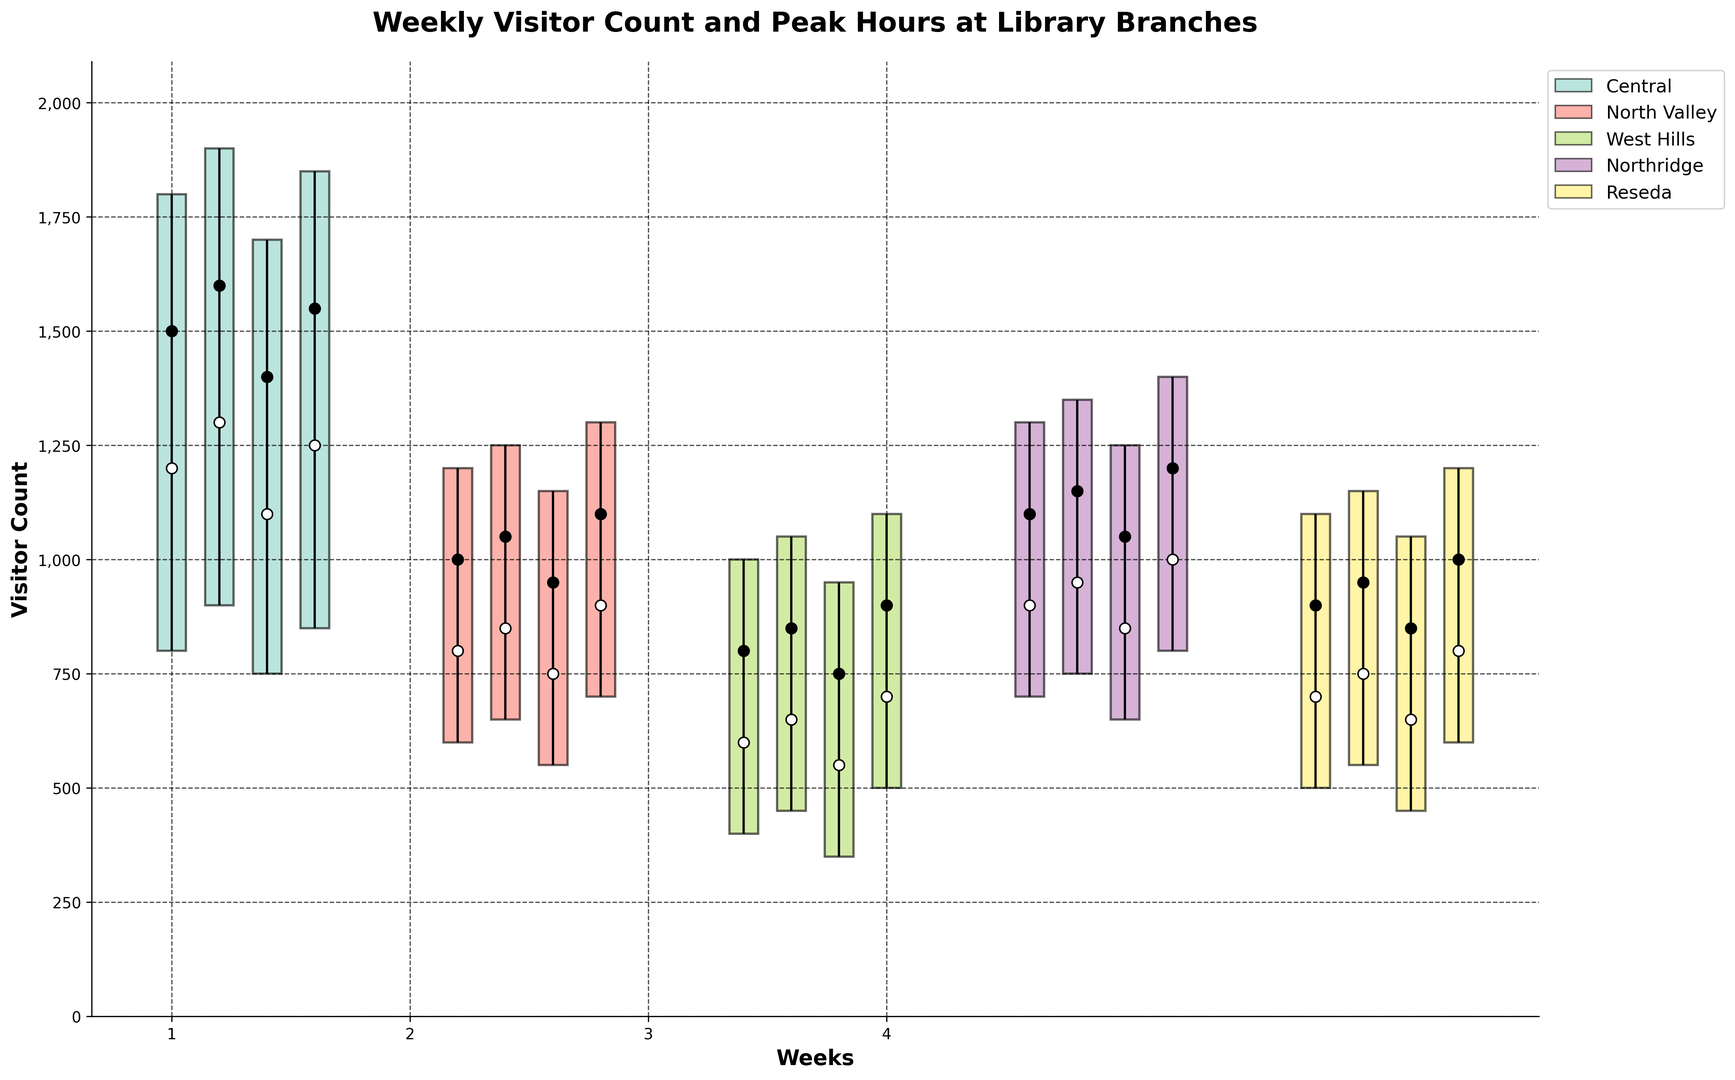Which branch had the highest peak visitor count in Week 1? In Week 1, compare the high values across all branches. The Central branch has the highest peak value of 1800.
Answer: Central What was the average opening visitor count for the Northridge branch across all weeks? Sum of opening counts for Northridge (900, 950, 850, 1000) is 3700, then divide by 4 weeks: 3700 / 4 = 925
Answer: 925 Which week had the smallest range of visitor counts at the North Valley branch? Calculate the range (High - Low) for each week at North Valley. Week 3 has the smallest range: 1150 - 550 = 600. Comparatively, other weeks have higher ranges.
Answer: Week 3 Between West Hills and Reseda branches, which one had a higher closing count average in Week 4? Closing count in Week 4: West Hills is 900, Reseda is 1000. Since 1000 > 900, Reseda is higher.
Answer: Reseda Which branch had the most consistent high values across all weeks? Consistently high values would be close to each other. The Central branch has high values 1800, 1900, 1700, 1850—a comparatively narrow range around 1800-1900.
Answer: Central How many weeks did the Reseda branch have an opening count lower than the closing count? Check each week for Reseda: Week 1 (700 < 900), Week 2 (750 < 950), Week 3 (650 < 850), Week 4 (800 < 1000). Reseda has 4 weeks with this pattern.
Answer: 4 Which branch has the highest variation in peak visitor counts across the four weeks? To determine variation, compare the difference between the highest and lowest 'High' values for each branch. Central: 1900 - 1700 = 200, North Valley: 1300 - 1150 = 150, West Hills: 1100 - 1000 = 100, Northridge: 1400 - 1250 = 150, Reseda: 1200 - 1050 = 150. Central has the highest variation.
Answer: Central What's the total visitor count range (difference between high and low) for Northridge in Week 4? The High value is 1400 and Low value is 800 in Week 4 for Northridge. Calculate the range: 1400 - 800 = 600.
Answer: 600 